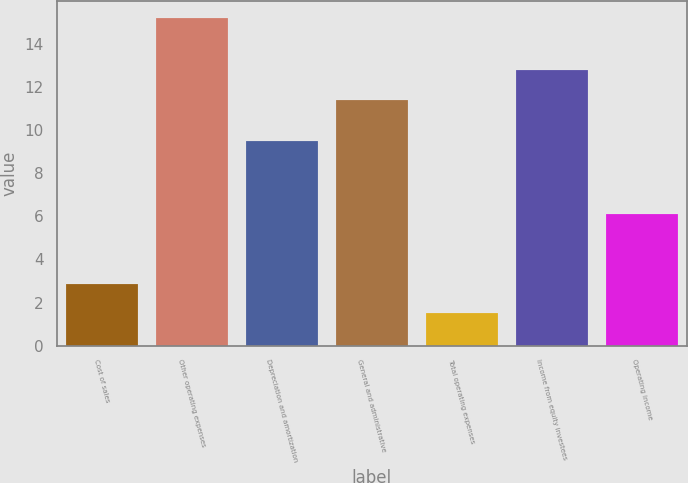<chart> <loc_0><loc_0><loc_500><loc_500><bar_chart><fcel>Cost of sales<fcel>Other operating expenses<fcel>Depreciation and amortization<fcel>General and administrative<fcel>Total operating expenses<fcel>Income from equity investees<fcel>Operating income<nl><fcel>2.87<fcel>15.2<fcel>9.5<fcel>11.4<fcel>1.5<fcel>12.77<fcel>6.1<nl></chart> 